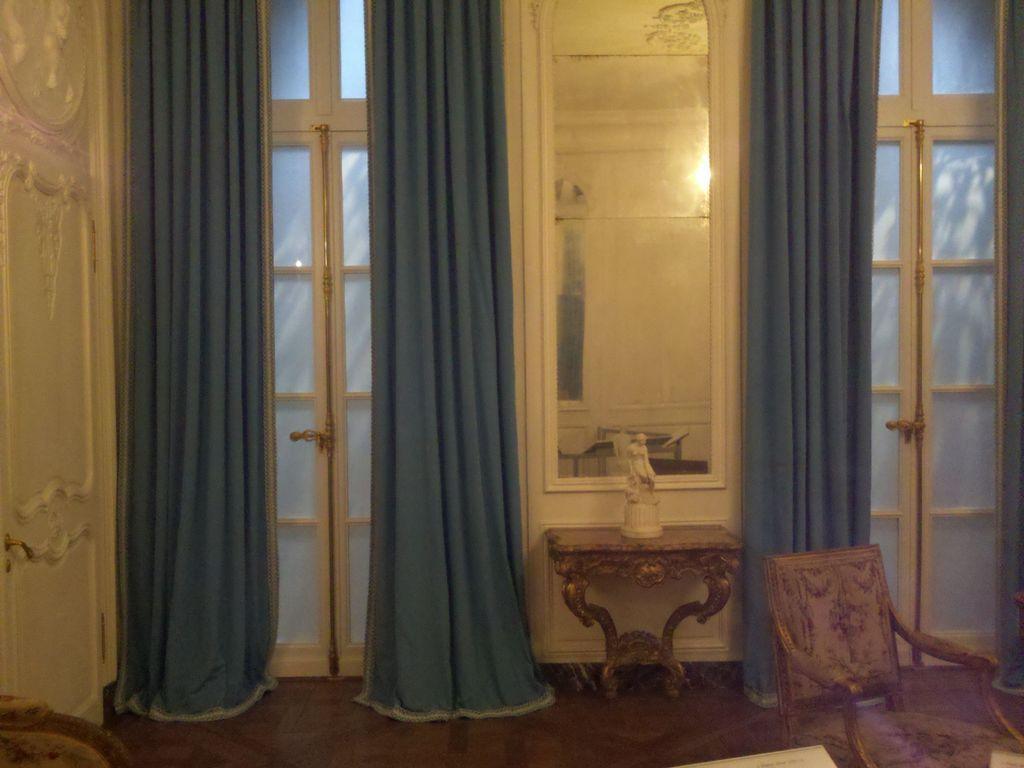Describe this image in one or two sentences. In this image I see a chair over here and I see a white color sculpture on this table and I see a mirror over her and I can also see curtains which are of blue in color and I see doors and I see the floor and I see the light in the reflection. 